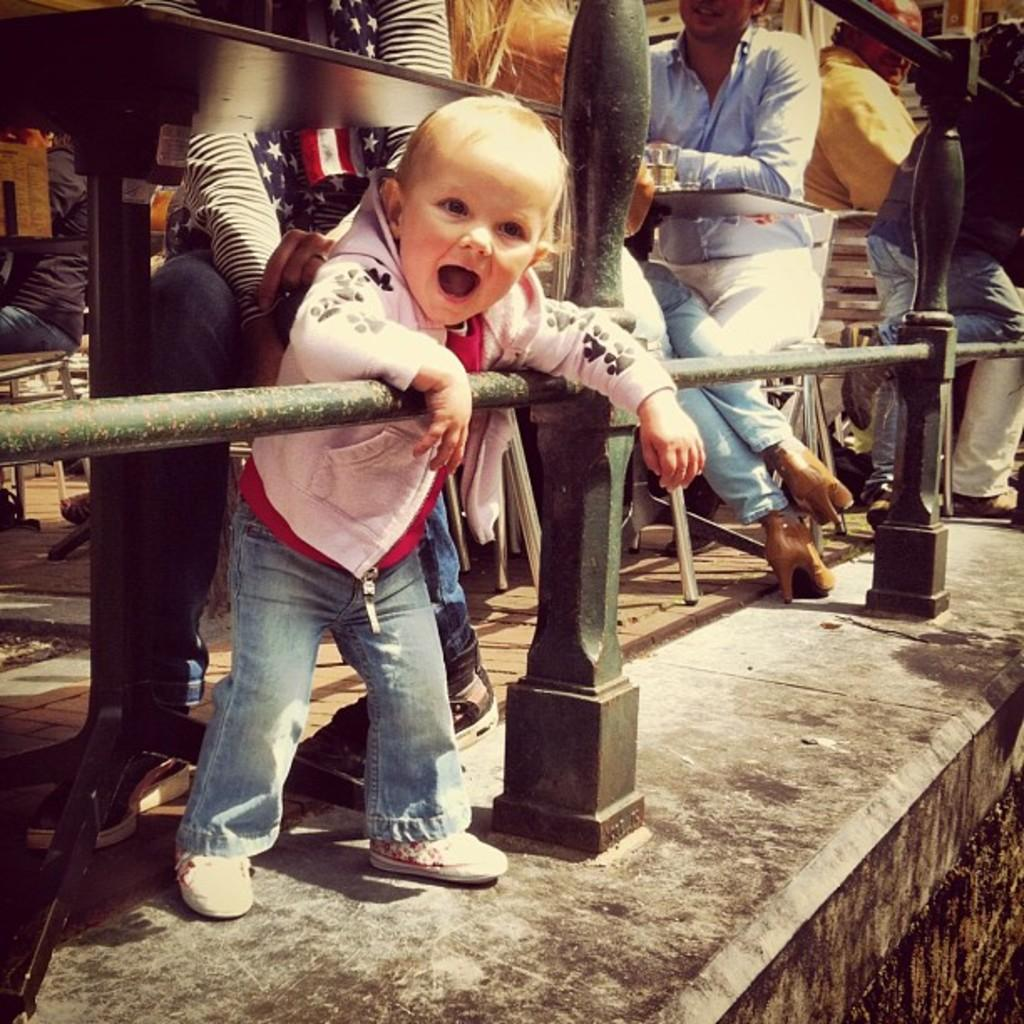What type of fence is present in the image? There is a pillar fence in the image. What are the people in the image doing? The persons in the image are sitting on chairs. Where are the chairs located in relation to the tables? The chairs are in front of the tables. What can be seen on the table in the image? There is a glass visible on the table. How many pages of the paper can be seen in the image? There is no paper present in the image, so it is not possible to determine the number of pages. 